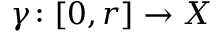<formula> <loc_0><loc_0><loc_500><loc_500>\gamma \colon [ 0 , r ] \to X</formula> 